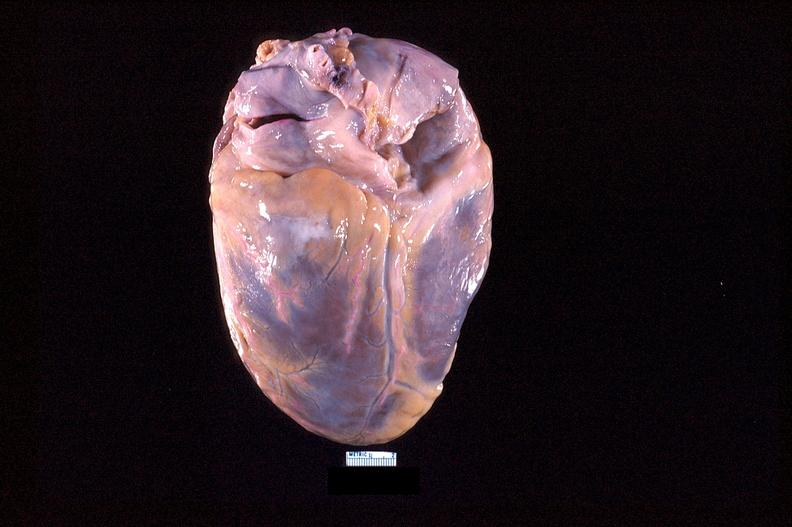what does this image show?
Answer the question using a single word or phrase. Heart 